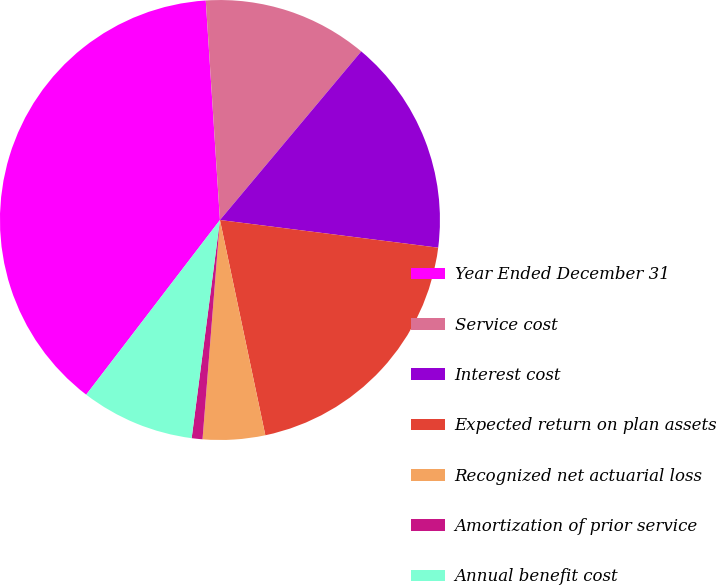Convert chart. <chart><loc_0><loc_0><loc_500><loc_500><pie_chart><fcel>Year Ended December 31<fcel>Service cost<fcel>Interest cost<fcel>Expected return on plan assets<fcel>Recognized net actuarial loss<fcel>Amortization of prior service<fcel>Annual benefit cost<nl><fcel>38.58%<fcel>12.13%<fcel>15.91%<fcel>19.69%<fcel>4.57%<fcel>0.79%<fcel>8.35%<nl></chart> 